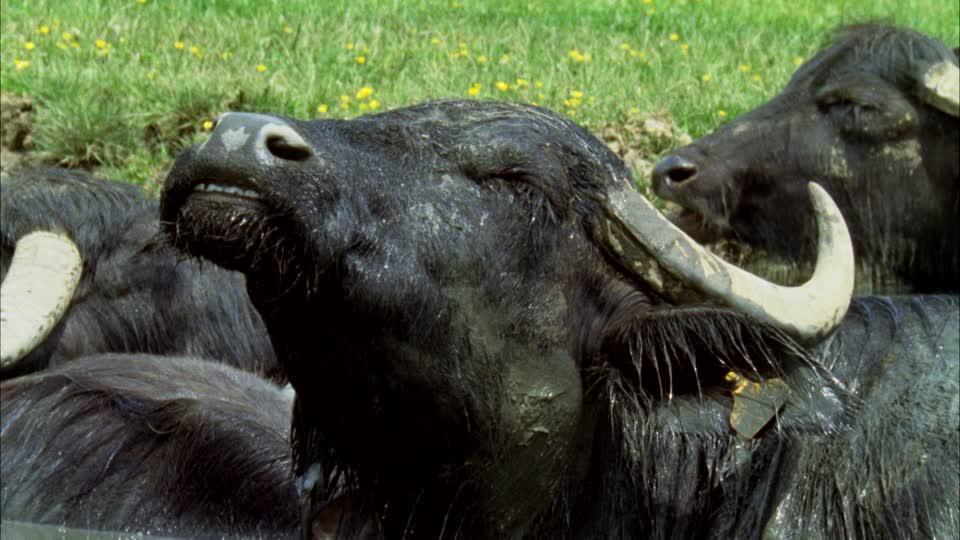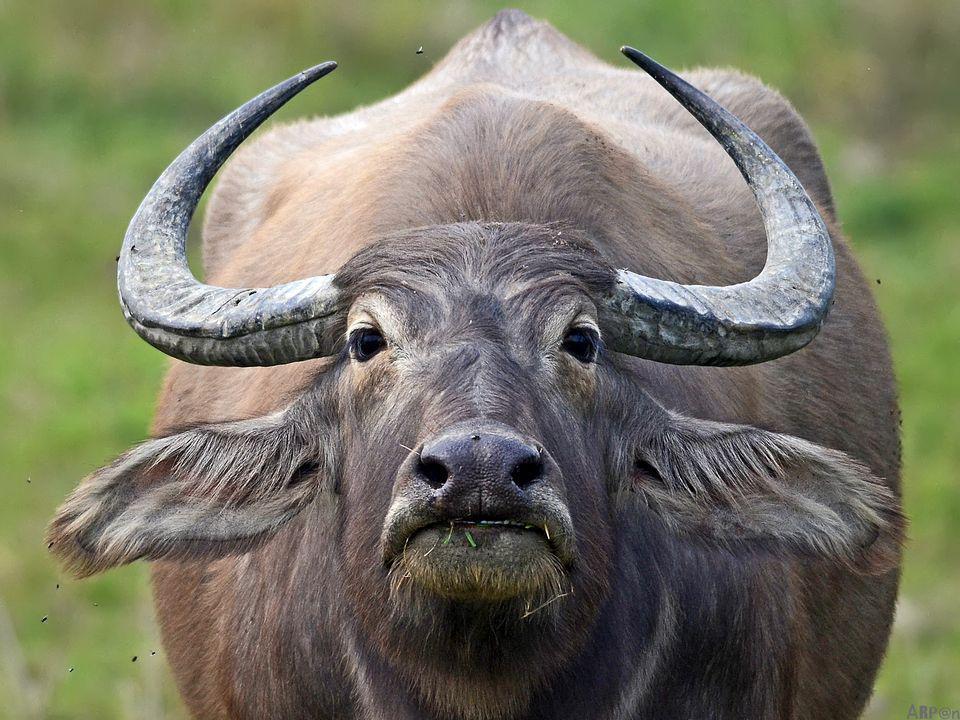The first image is the image on the left, the second image is the image on the right. Examine the images to the left and right. Is the description "IN at least one image there is a bull the is the same color as the dirt water it is in." accurate? Answer yes or no. No. The first image is the image on the left, the second image is the image on the right. For the images displayed, is the sentence "A buffalo is completely covered in mud." factually correct? Answer yes or no. No. 